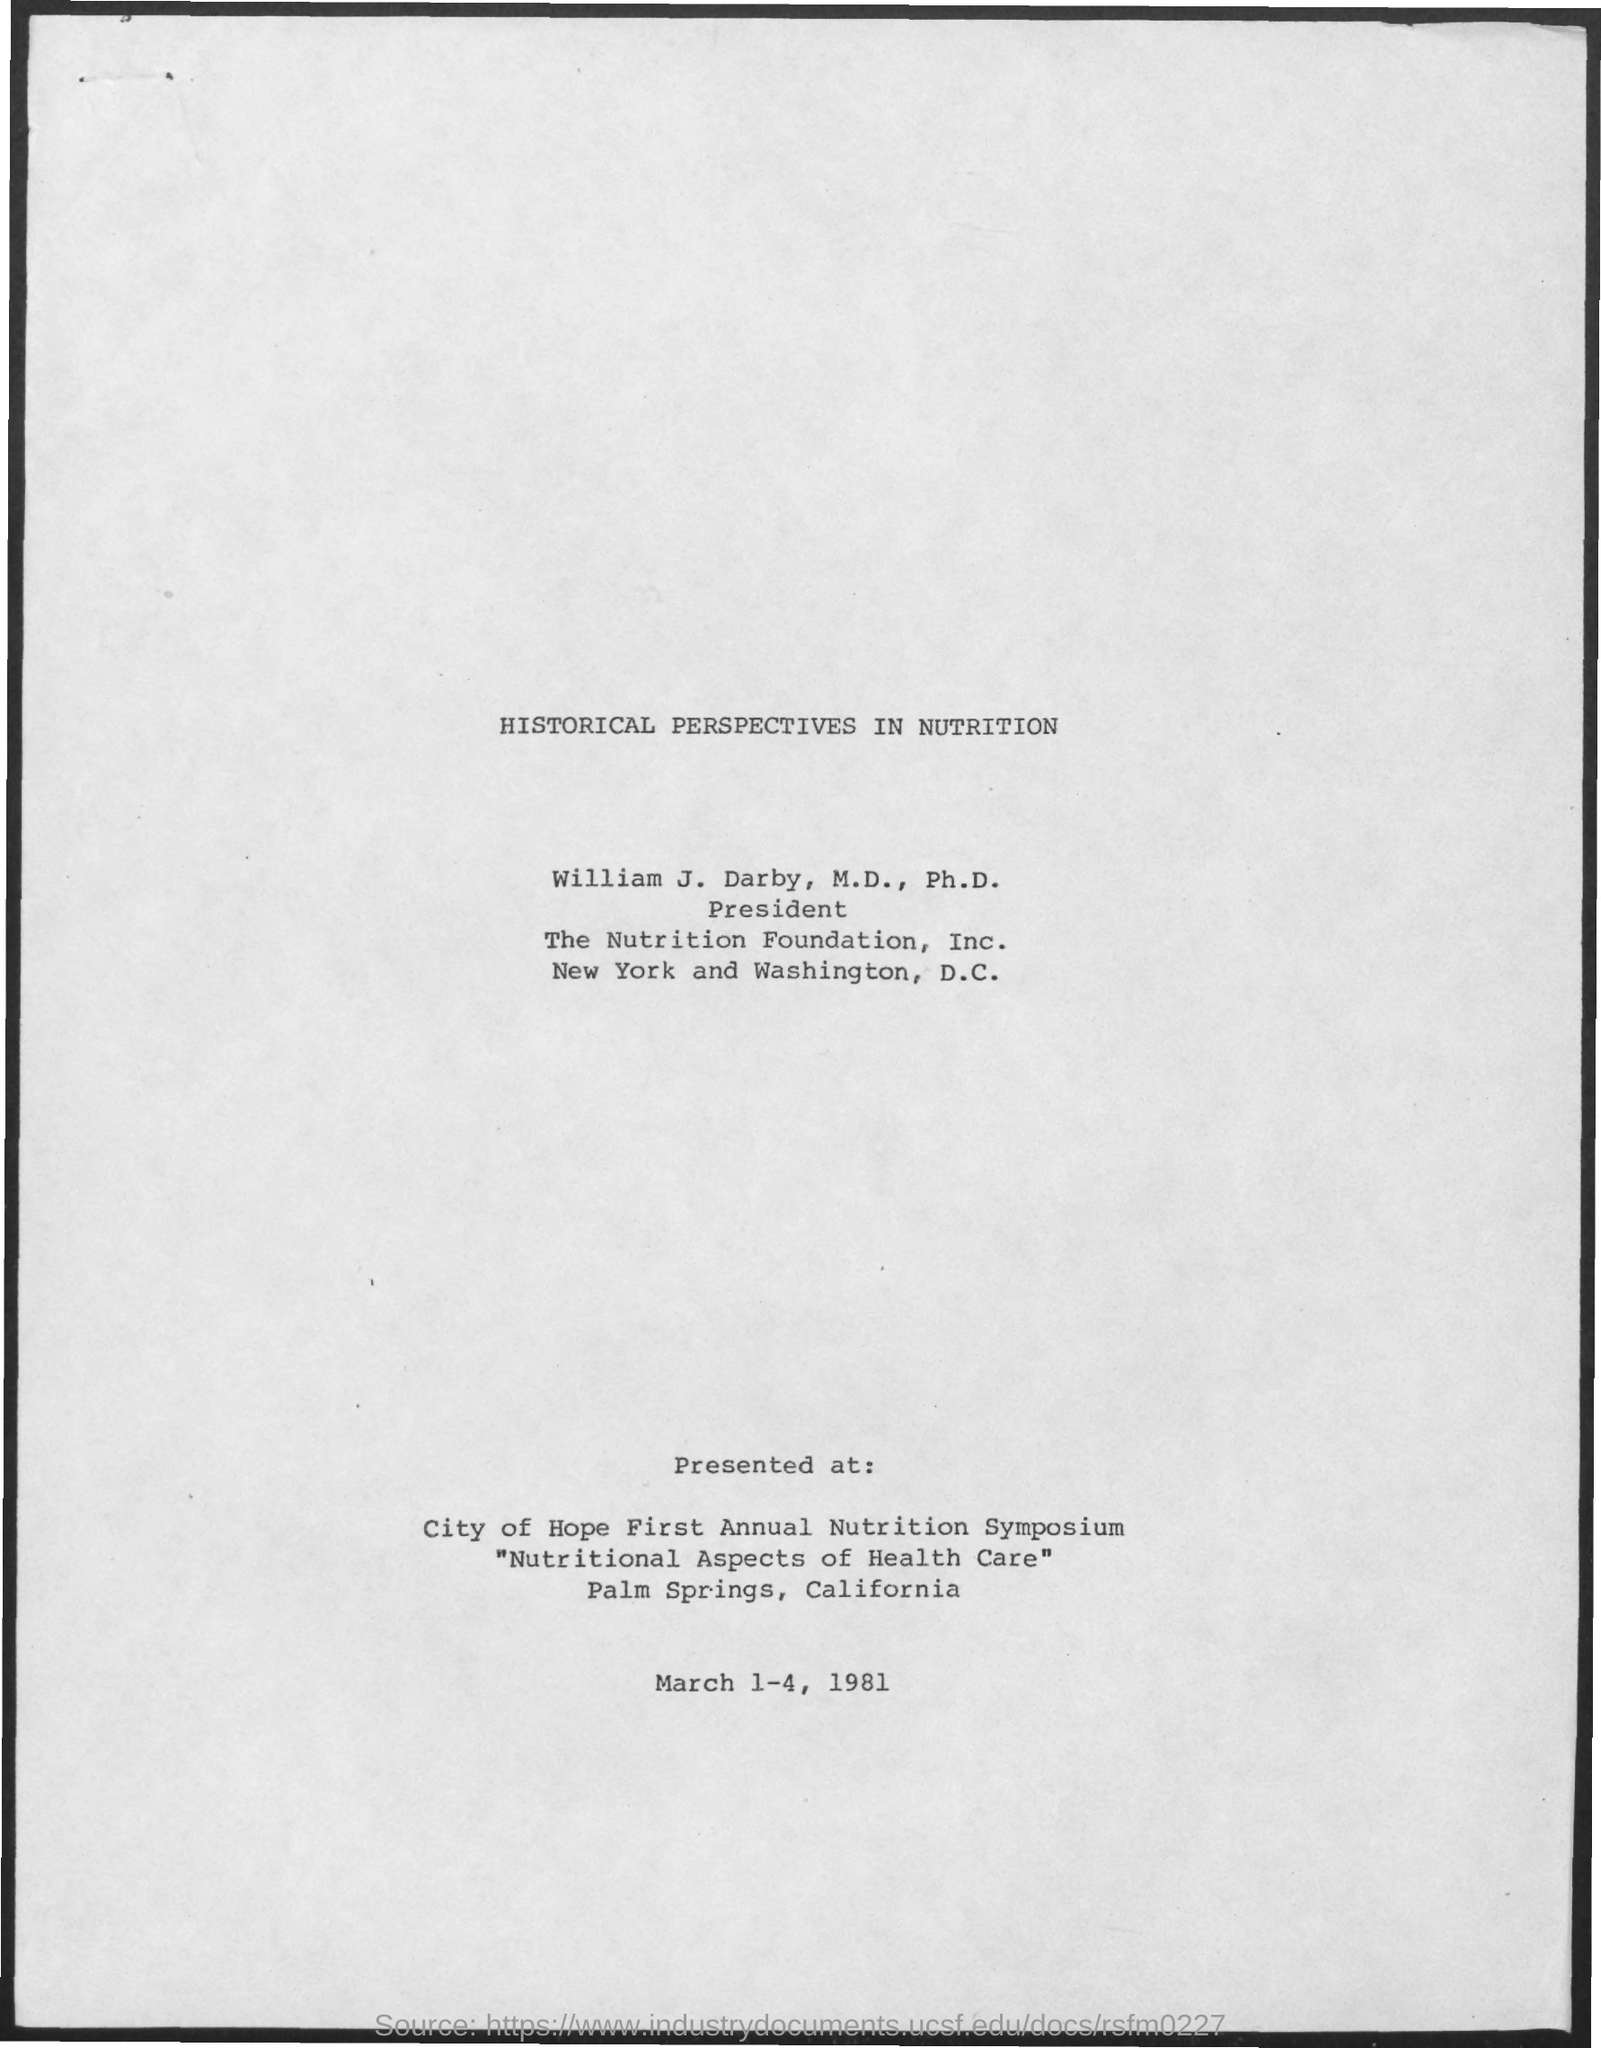What is the document about?
Ensure brevity in your answer.  HISTORICAL PERSPECTIVES IN NUTRITION. Where was the presentation?
Your answer should be compact. City of Hope First Annual Nutrition Symposium. When was the presentation?
Provide a short and direct response. March 1-4, 1981. 